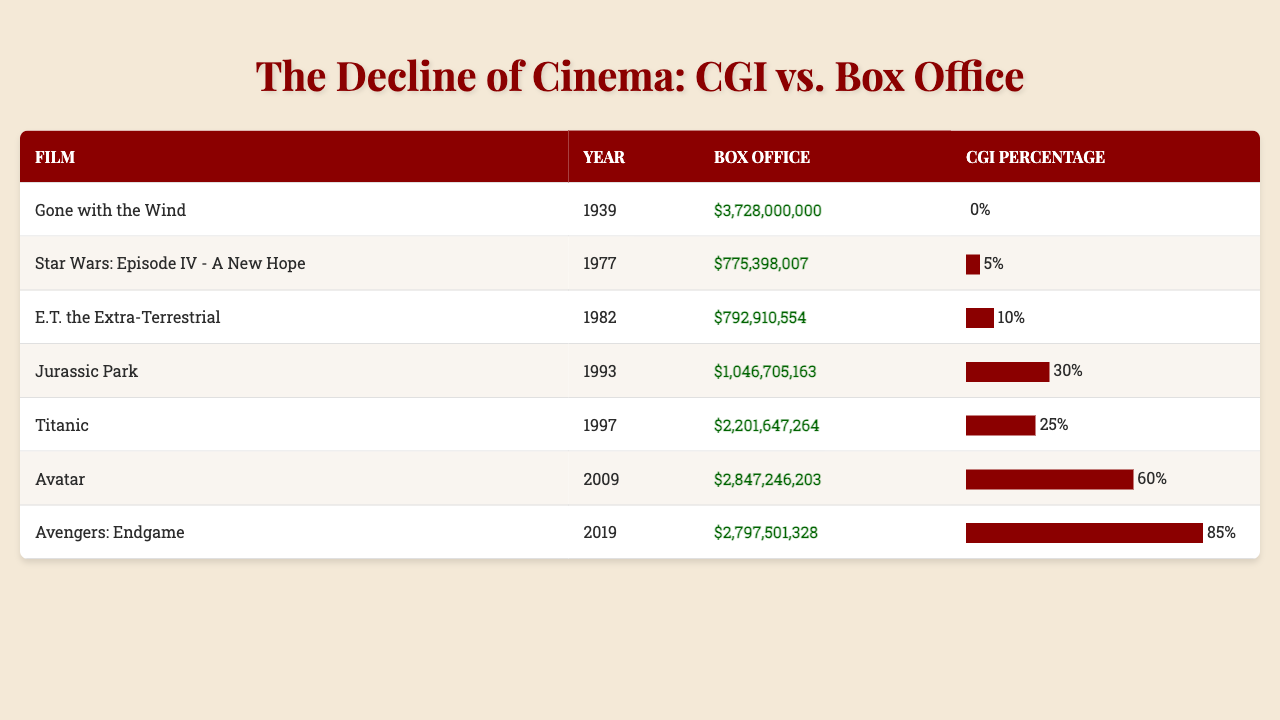What is the highest box office earning film on the list? By scanning the box office column in the table, "Gone with the Wind" has the highest earnings of $3,728,000,000.
Answer: $3,728,000,000 Which film has the lowest CGI percentage and what is that percentage? Looking at the CGI percentage column, "Gone with the Wind" has the lowest CGI percentage at 0%.
Answer: 0% What is the total box office earnings of all films listed? To find the total, I add up all the box office earnings: 3728000000 + 775398007 + 792910554 + 1046705163 + 2201647264 + 2847246203 + 2797501328 =  10142021220.
Answer: $10,142,021,220 Which film released in 1997 has a box office earning greater than $2 billion? "Titanic," released in 1997, has a box office earning of $2,201,647,264, which is greater than $2 billion.
Answer: Titanic How much higher is the box office earning of "Avatar" compared to "E.T. the Extra-Terrestrial"? The box office earning for "Avatar" is $2,847,246,203 and for "E.T. the Extra-Terrestrial" it is $792,910,554. The difference is $2,847,246,203 - $792,910,554 = $2,054,335,649.
Answer: $2,054,335,649 What percentage of films have a CGI percentage of 25% or higher? There are 7 films listed. "Jurassic Park" (30%), "Titanic" (25%), "Avatar" (60%), and "Avengers: Endgame" (85%) all have CGI percentages of 25% or higher, totaling 4 films. The percentage is (4/7) * 100 = 57.14%, so approximately 57%.
Answer: 57% Is "Avengers: Endgame" the only film with a CGI percentage over 80%? By reviewing the CGI percentage column, "Avengers: Endgame" is the only film listed with a CGI percentage of 85%, confirming that it is indeed the only one over 80%.
Answer: Yes What is the average CGI percentage of all the films listed? To find the average, calculate the sum of the CGI percentages (0 + 5 + 10 + 30 + 25 + 60 + 85 = 215) and then divide by the number of films (7): 215/7 = 30.71%, approximately 31%.
Answer: 31% Which film had the highest CGI percentage and what is the value? Checking the CGI percentage column, "Avengers: Endgame" holds the highest CGI percentage at 85%.
Answer: 85% 